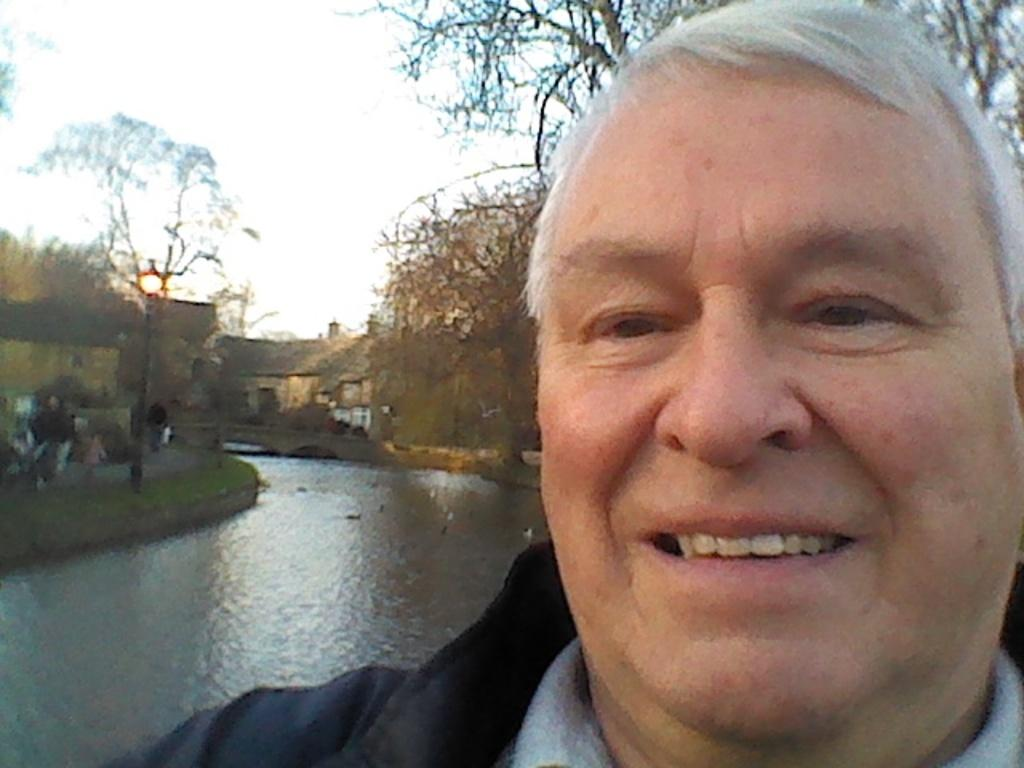What is the main subject of the image? The main subject of the image is a group of people. Can you describe the man on the right side of the image? The man on the right side of the image is smiling. What is visible behind the man? There is water visible behind the man. What can be seen in the background of the image? There are trees and houses in the background of the image. What type of flowers can be seen growing around the man's feet in the image? There are no flowers visible in the image; the man is standing near water with trees and houses in the background. 